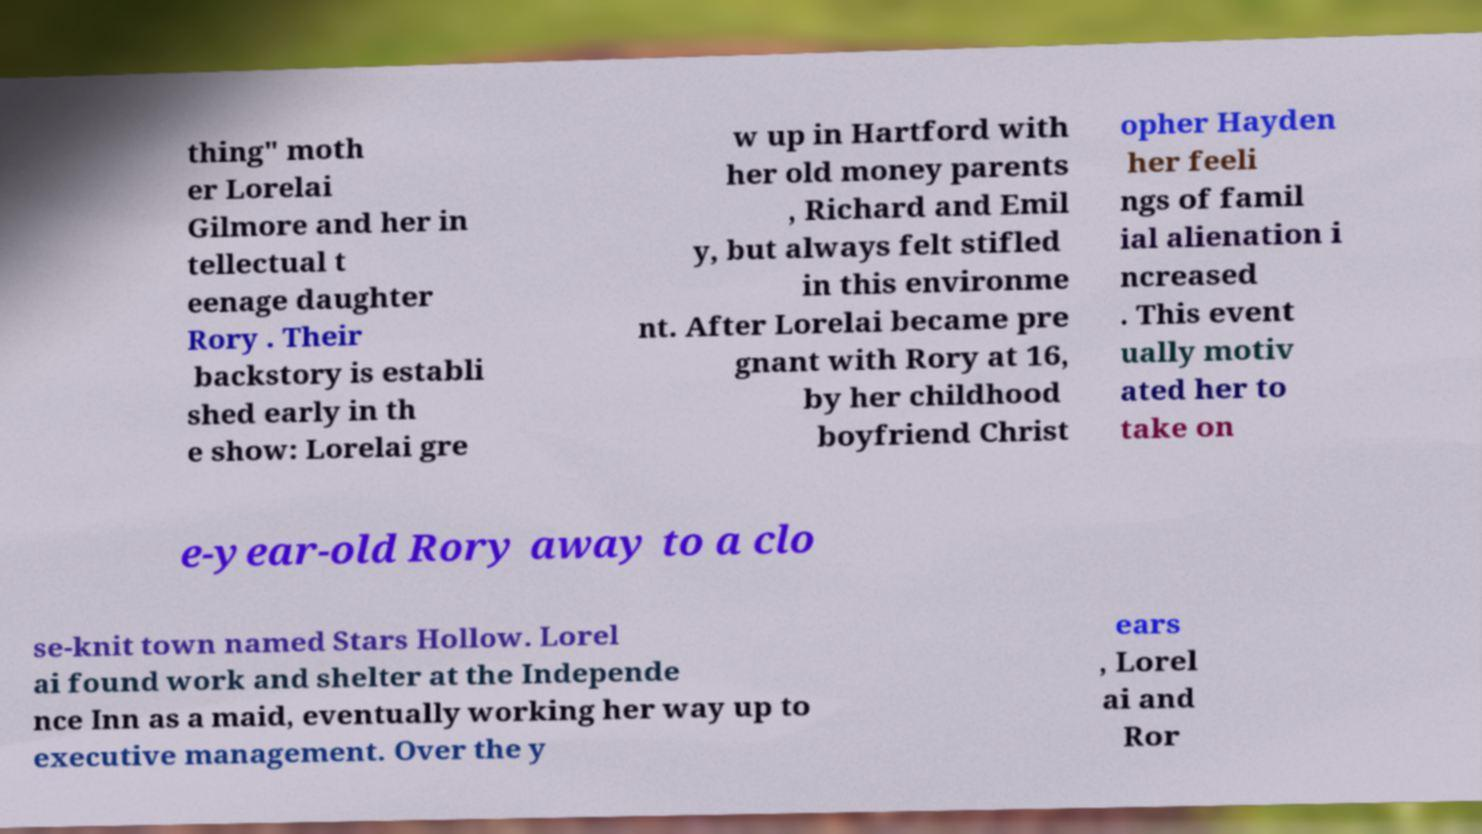Please read and relay the text visible in this image. What does it say? thing" moth er Lorelai Gilmore and her in tellectual t eenage daughter Rory . Their backstory is establi shed early in th e show: Lorelai gre w up in Hartford with her old money parents , Richard and Emil y, but always felt stifled in this environme nt. After Lorelai became pre gnant with Rory at 16, by her childhood boyfriend Christ opher Hayden her feeli ngs of famil ial alienation i ncreased . This event ually motiv ated her to take on e-year-old Rory away to a clo se-knit town named Stars Hollow. Lorel ai found work and shelter at the Independe nce Inn as a maid, eventually working her way up to executive management. Over the y ears , Lorel ai and Ror 